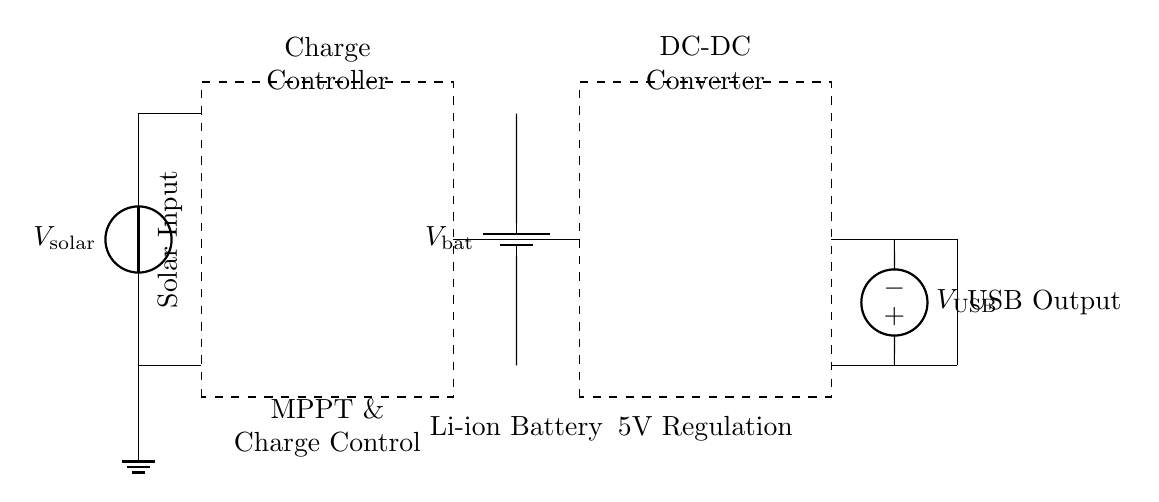What is the input voltage to the charge controller? The input voltage to the charge controller is the voltage delivered by the solar panel, denoted as V_solar.
Answer: V_solar What component regulates the voltage for USB output? The DC-DC converter is the component responsible for regulating the voltage to ensure it is suitable for USB output, which is typically 5V.
Answer: DC-DC converter How many major components are present in the circuit? The circuit features four major components: the solar panel, the charge controller, the battery, and the DC-DC converter.
Answer: Four What type of battery is used in the circuit? The circuit uses a Li-ion battery, as labeled next to the corresponding component.
Answer: Li-ion What does the charge controller ensure besides charging the battery? The charge controller ensures maximum power point tracking (MPPT) to optimize energy harvest from the solar panel, in addition to controlling the charging process.
Answer: MPPT What is the output voltage specification for the USB output? The output voltage specification for the USB output is denoted as V_USB, which typically corresponds to 5V in charging circuits.
Answer: V_USB 